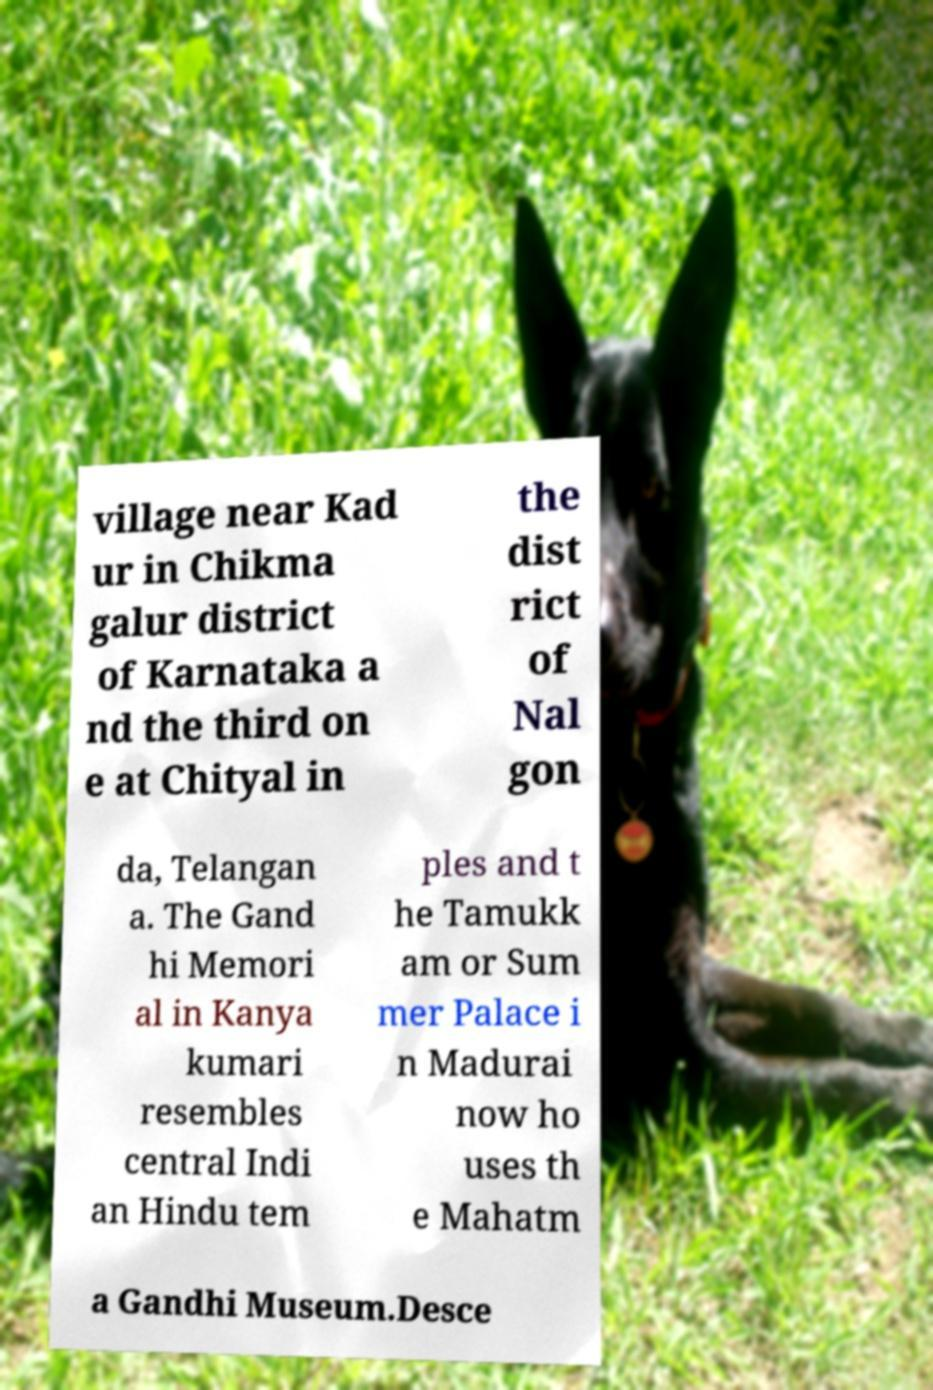There's text embedded in this image that I need extracted. Can you transcribe it verbatim? village near Kad ur in Chikma galur district of Karnataka a nd the third on e at Chityal in the dist rict of Nal gon da, Telangan a. The Gand hi Memori al in Kanya kumari resembles central Indi an Hindu tem ples and t he Tamukk am or Sum mer Palace i n Madurai now ho uses th e Mahatm a Gandhi Museum.Desce 